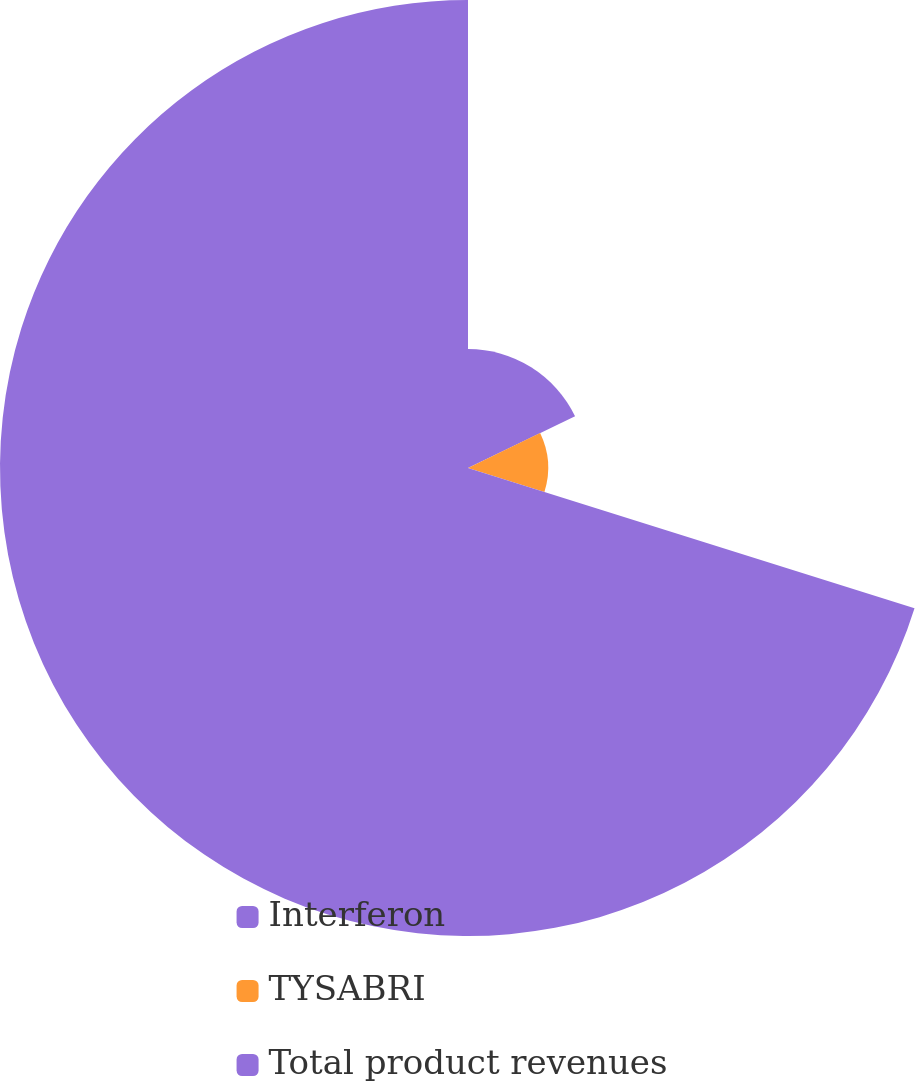<chart> <loc_0><loc_0><loc_500><loc_500><pie_chart><fcel>Interferon<fcel>TYSABRI<fcel>Total product revenues<nl><fcel>17.83%<fcel>12.01%<fcel>70.16%<nl></chart> 